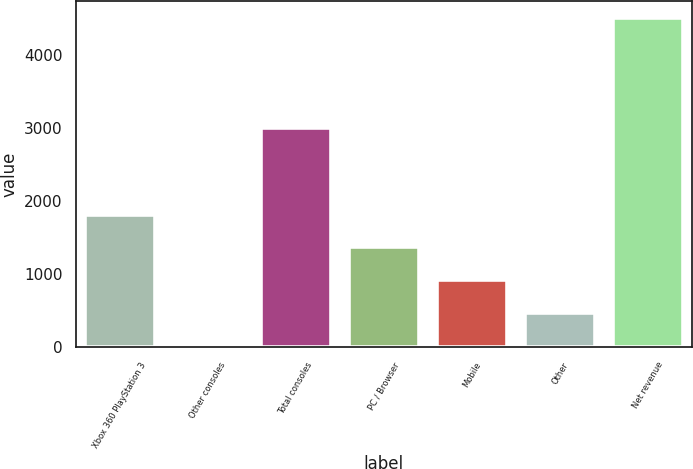Convert chart to OTSL. <chart><loc_0><loc_0><loc_500><loc_500><bar_chart><fcel>Xbox 360 PlayStation 3<fcel>Other consoles<fcel>Total consoles<fcel>PC / Browser<fcel>Mobile<fcel>Other<fcel>Net revenue<nl><fcel>1818.6<fcel>21<fcel>3011<fcel>1369.2<fcel>919.8<fcel>470.4<fcel>4515<nl></chart> 